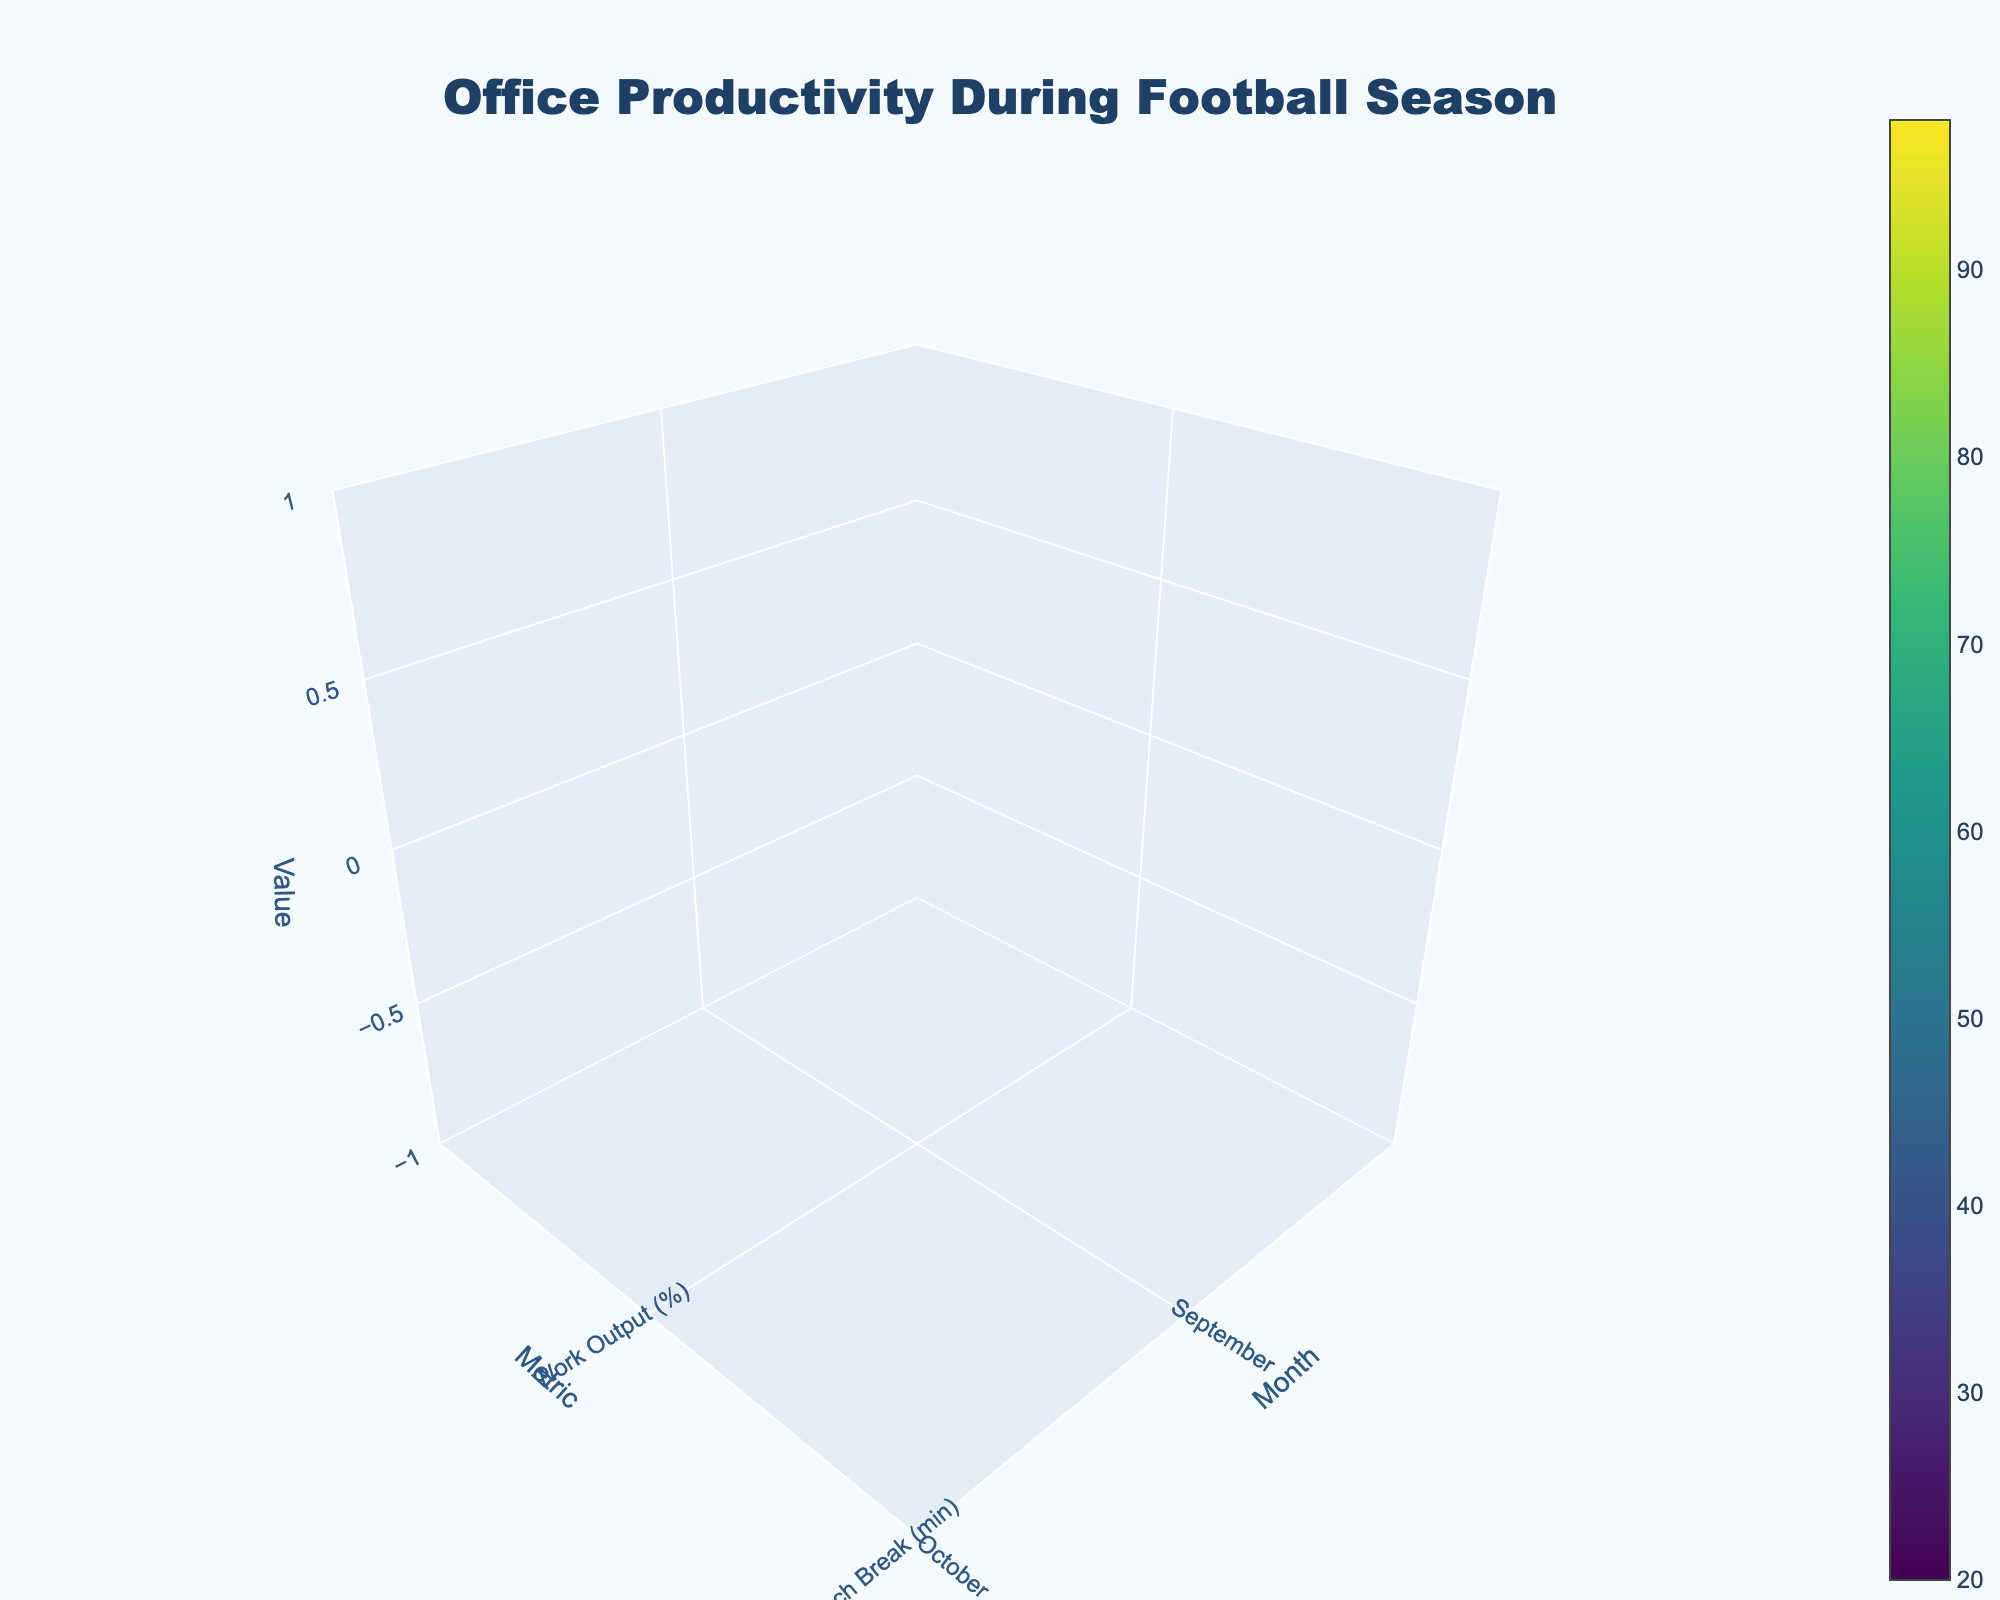What's the title of the plot? The title is given explicitly in the figure, usually located at the top center of the plot. Here, it reads "Office Productivity During Football Season".
Answer: Office Productivity During Football Season What months are covered in this plot? The x-axis represents time in months, with tick texts labeled September, October, November, December, January, and February.
Answer: September to February Which metric has the highest value in February? By visual inspection, the highest z-axis value in February (far right of the x-axis) is significantly ascribed to Work Output (%).
Answer: Work Output (%) How does the duration of lunch breaks change from September to December? The y-axis labeled 'Lunch Break (min)' shows an increasing trend as you move from September to December on the x-axis. September starts lower, increasing gradually each month.
Answer: Increases In which month does the time spent discussing sports peak? By examining the third row on the z-axis (representing 'Sports Discussion (min)'), the tallest value is visible in December.
Answer: December What is the work output difference between October and January? Locate the 'Work Output (%)' row on the y-axis for October and January. Subtract their z-values (92% in October and 90% in January).
Answer: 2% Which month has the shortest lunch break duration, and what is that duration? Identify the minimum z-value in the 'Lunch Break (min)' row across all months. The shortest duration is seen in February, at 40 minutes.
Answer: February, 40 minutes How does the amount of time spent discussing sports in January compare to that in November? Comparing the 'Sports Discussion (min)' row for January and November, January has 50 minutes, and November has 60 minutes of sports discussions. So, January is less.
Answer: Less in January Calculate the average work output across all months. Add the work output percentages for all months (95, 92, 88, 85, 90, 98) and divide by the number of months (6). The sum is 548, so 548/6 = approximately 91.33%.
Answer: 91.33% What's the trend of work output over the football season? Follow the 'Work Output (%)' row through the months from September to February. It decreases from September to December and then increases again in January and February.
Answer: Decrease then Increase 